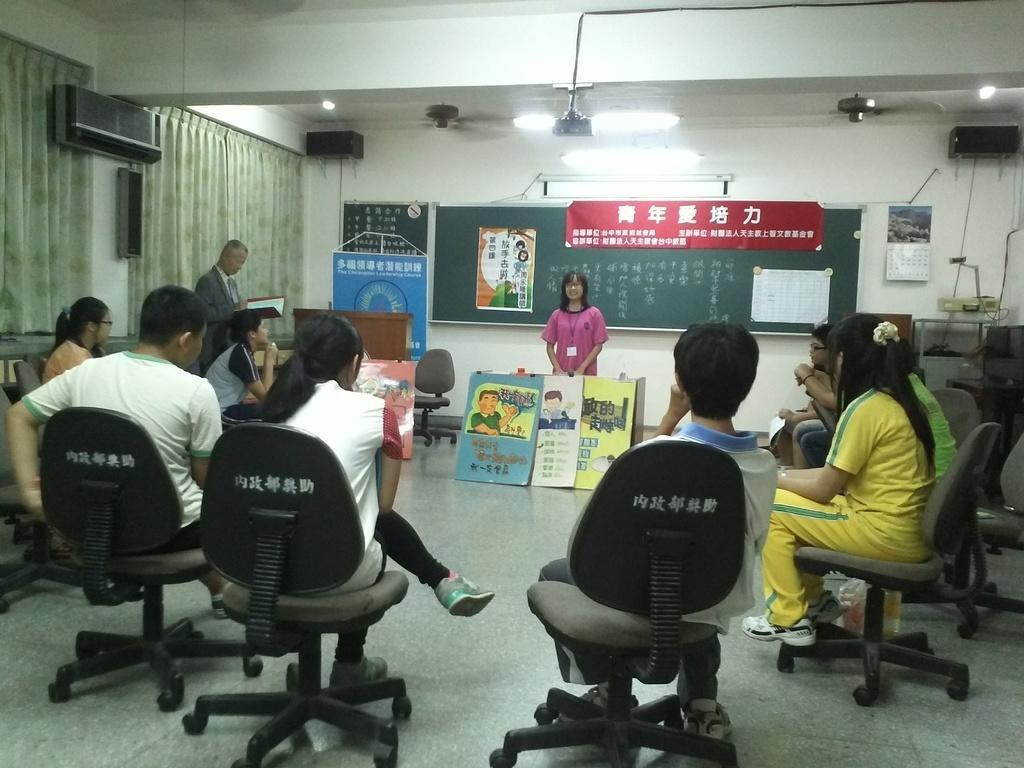How would you summarize this image in a sentence or two? In this image there are group of people siting on the chair. The woman is standing. At the back side there is a board and curtains. 